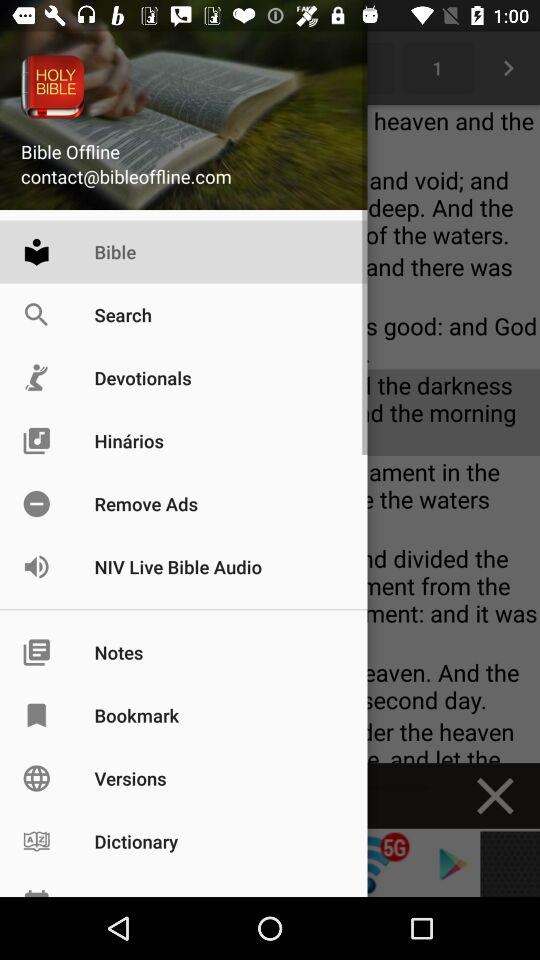What is the name of the application? The name of the application is "Bible Offline". 